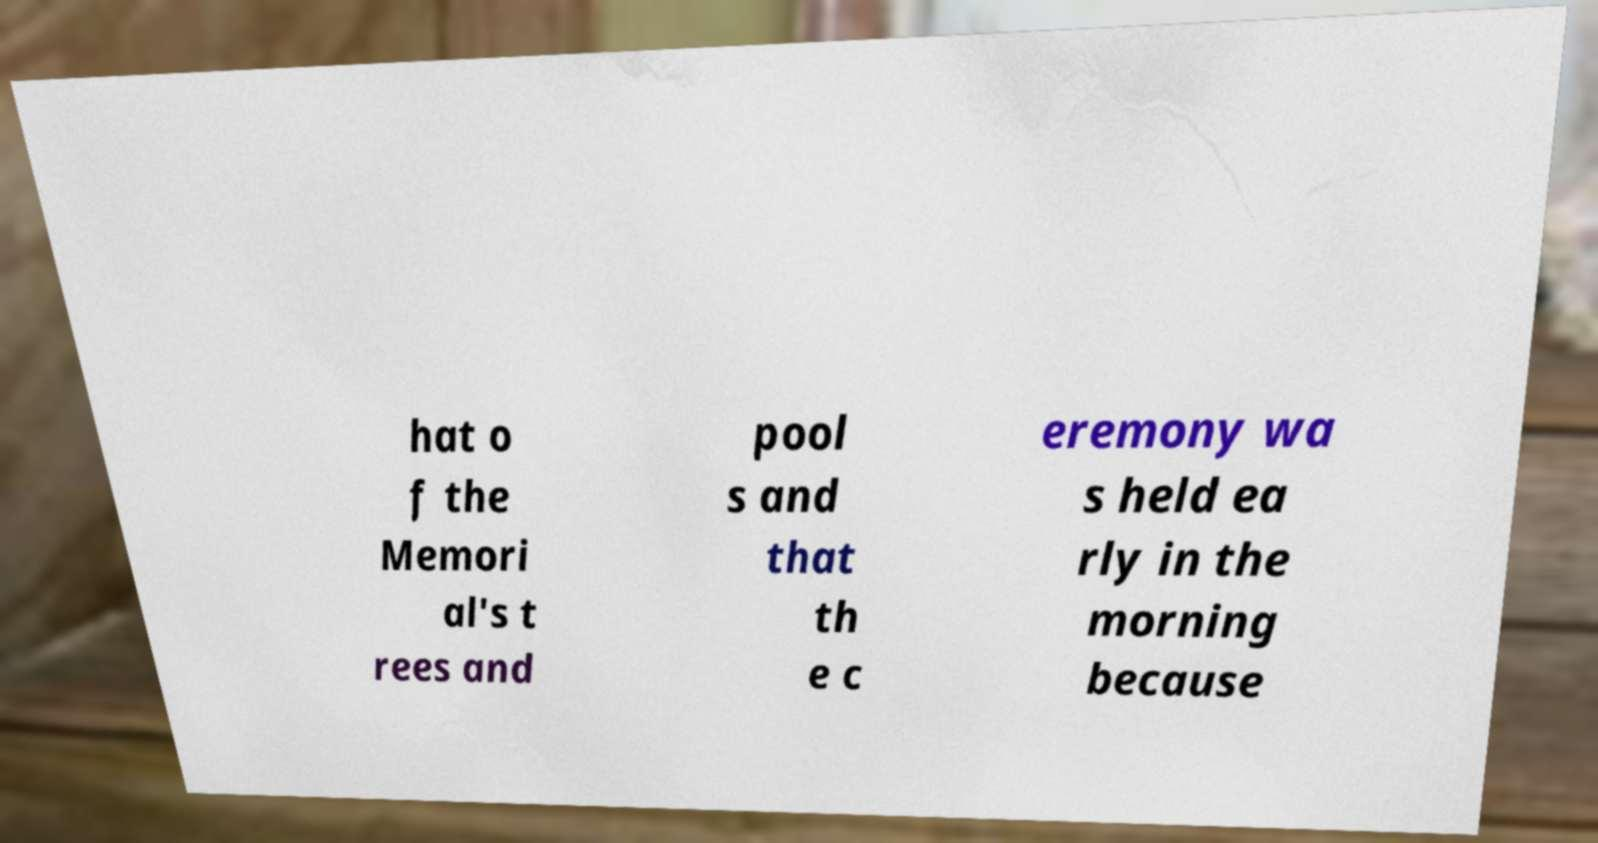What messages or text are displayed in this image? I need them in a readable, typed format. hat o f the Memori al's t rees and pool s and that th e c eremony wa s held ea rly in the morning because 